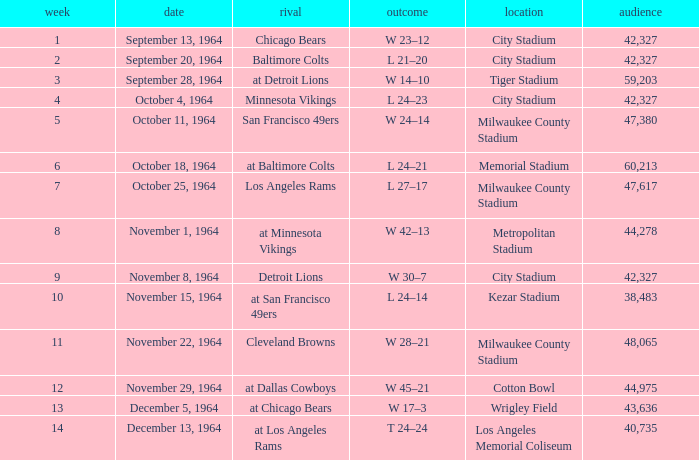What is the average week of the game on November 22, 1964 attended by 48,065? None. 